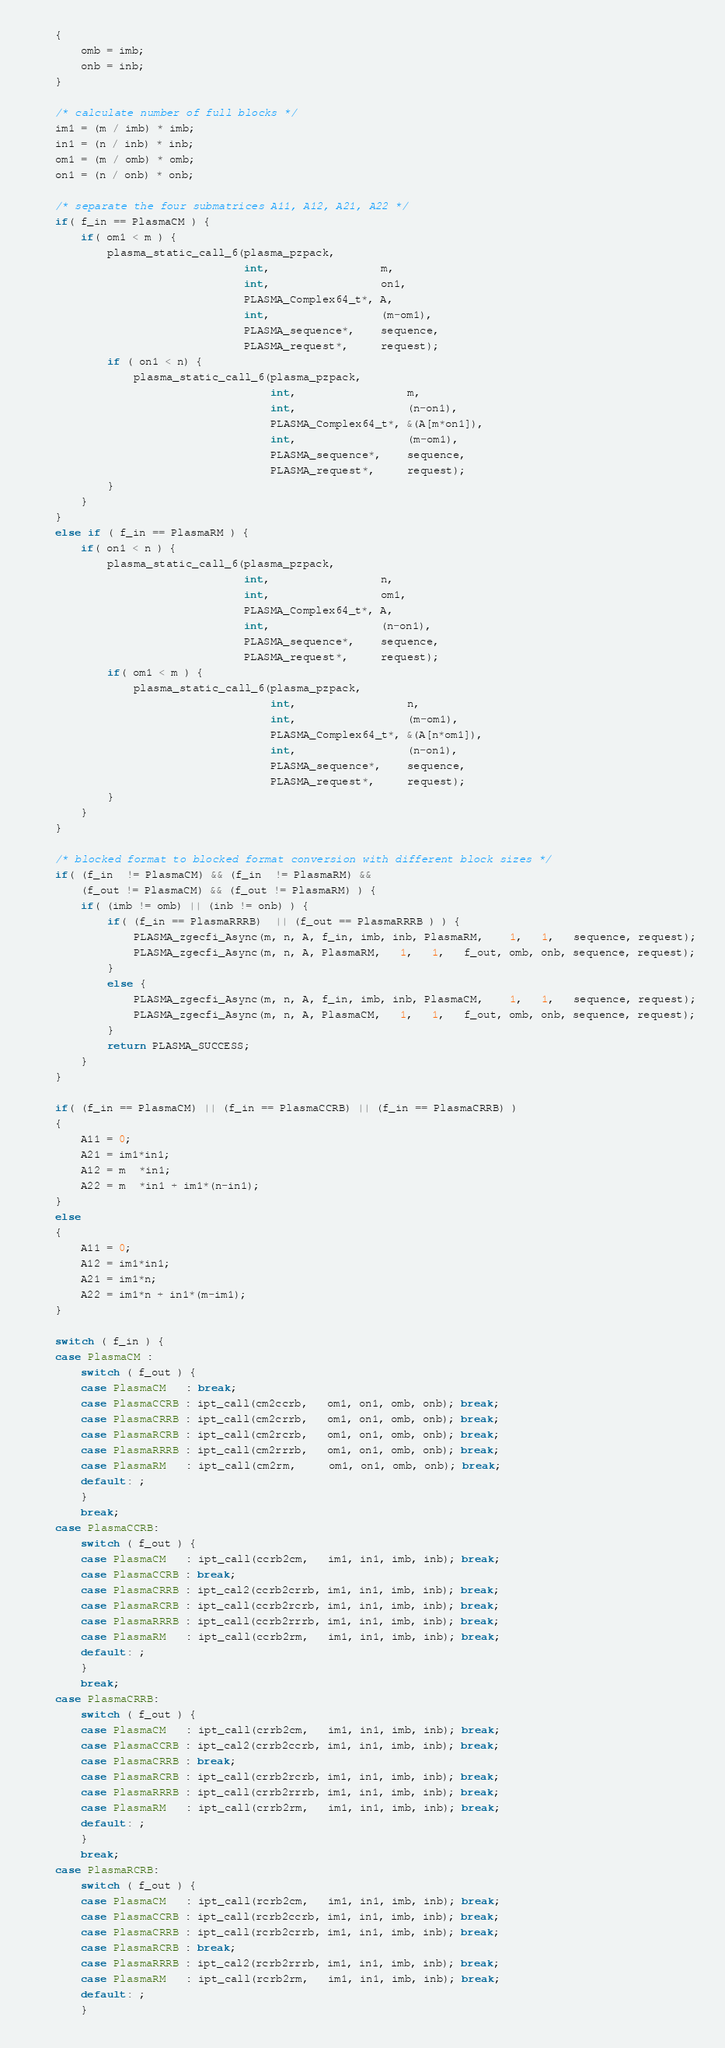Convert code to text. <code><loc_0><loc_0><loc_500><loc_500><_C_>    {
        omb = imb;
        onb = inb;
    }

    /* calculate number of full blocks */
    im1 = (m / imb) * imb;
    in1 = (n / inb) * inb;
    om1 = (m / omb) * omb;
    on1 = (n / onb) * onb;

    /* separate the four submatrices A11, A12, A21, A22 */
    if( f_in == PlasmaCM ) {
        if( om1 < m ) {
            plasma_static_call_6(plasma_pzpack,
                                 int,                 m,
                                 int,                 on1,
                                 PLASMA_Complex64_t*, A,
                                 int,                 (m-om1),
                                 PLASMA_sequence*,    sequence,
                                 PLASMA_request*,     request);
            if ( on1 < n) {
                plasma_static_call_6(plasma_pzpack,
                                     int,                 m,
                                     int,                 (n-on1),
                                     PLASMA_Complex64_t*, &(A[m*on1]),
                                     int,                 (m-om1),
                                     PLASMA_sequence*,    sequence,
                                     PLASMA_request*,     request);
            }
        }
    }
    else if ( f_in == PlasmaRM ) {
        if( on1 < n ) {
            plasma_static_call_6(plasma_pzpack,
                                 int,                 n,
                                 int,                 om1,
                                 PLASMA_Complex64_t*, A,
                                 int,                 (n-on1),
                                 PLASMA_sequence*,    sequence,
                                 PLASMA_request*,     request);
            if( om1 < m ) {
                plasma_static_call_6(plasma_pzpack,
                                     int,                 n,
                                     int,                 (m-om1),
                                     PLASMA_Complex64_t*, &(A[n*om1]),
                                     int,                 (n-on1),
                                     PLASMA_sequence*,    sequence,
                                     PLASMA_request*,     request);
            }
        }
    }

    /* blocked format to blocked format conversion with different block sizes */
    if( (f_in  != PlasmaCM) && (f_in  != PlasmaRM) &&
        (f_out != PlasmaCM) && (f_out != PlasmaRM) ) {
        if( (imb != omb) || (inb != onb) ) {
            if( (f_in == PlasmaRRRB)  || (f_out == PlasmaRRRB ) ) {
                PLASMA_zgecfi_Async(m, n, A, f_in, imb, inb, PlasmaRM,    1,   1,   sequence, request);
                PLASMA_zgecfi_Async(m, n, A, PlasmaRM,   1,   1,   f_out, omb, onb, sequence, request);
            }
            else {
                PLASMA_zgecfi_Async(m, n, A, f_in, imb, inb, PlasmaCM,    1,   1,   sequence, request);
                PLASMA_zgecfi_Async(m, n, A, PlasmaCM,   1,   1,   f_out, omb, onb, sequence, request);
            }
            return PLASMA_SUCCESS;
        }
    }

    if( (f_in == PlasmaCM) || (f_in == PlasmaCCRB) || (f_in == PlasmaCRRB) )
    {
        A11 = 0;
        A21 = im1*in1;
        A12 = m  *in1;
        A22 = m  *in1 + im1*(n-in1);
    }
    else
    {
        A11 = 0;
        A12 = im1*in1;
        A21 = im1*n;
        A22 = im1*n + in1*(m-im1);
    }

    switch ( f_in ) {
    case PlasmaCM :
        switch ( f_out ) {
        case PlasmaCM   : break;
        case PlasmaCCRB : ipt_call(cm2ccrb,   om1, on1, omb, onb); break;
        case PlasmaCRRB : ipt_call(cm2crrb,   om1, on1, omb, onb); break;
        case PlasmaRCRB : ipt_call(cm2rcrb,   om1, on1, omb, onb); break;
        case PlasmaRRRB : ipt_call(cm2rrrb,   om1, on1, omb, onb); break;
        case PlasmaRM   : ipt_call(cm2rm,     om1, on1, omb, onb); break;
        default: ;
        }
        break;
    case PlasmaCCRB:
        switch ( f_out ) {
        case PlasmaCM   : ipt_call(ccrb2cm,   im1, in1, imb, inb); break;
        case PlasmaCCRB : break;
        case PlasmaCRRB : ipt_cal2(ccrb2crrb, im1, in1, imb, inb); break;
        case PlasmaRCRB : ipt_call(ccrb2rcrb, im1, in1, imb, inb); break;
        case PlasmaRRRB : ipt_call(ccrb2rrrb, im1, in1, imb, inb); break;
        case PlasmaRM   : ipt_call(ccrb2rm,   im1, in1, imb, inb); break;
        default: ;
        }
        break;
    case PlasmaCRRB:
        switch ( f_out ) {
        case PlasmaCM   : ipt_call(crrb2cm,   im1, in1, imb, inb); break;
        case PlasmaCCRB : ipt_cal2(crrb2ccrb, im1, in1, imb, inb); break;
        case PlasmaCRRB : break;
        case PlasmaRCRB : ipt_call(crrb2rcrb, im1, in1, imb, inb); break;
        case PlasmaRRRB : ipt_call(crrb2rrrb, im1, in1, imb, inb); break;
        case PlasmaRM   : ipt_call(crrb2rm,   im1, in1, imb, inb); break;
        default: ;
        }
        break;
    case PlasmaRCRB:
        switch ( f_out ) {
        case PlasmaCM   : ipt_call(rcrb2cm,   im1, in1, imb, inb); break;
        case PlasmaCCRB : ipt_call(rcrb2ccrb, im1, in1, imb, inb); break;
        case PlasmaCRRB : ipt_call(rcrb2crrb, im1, in1, imb, inb); break;
        case PlasmaRCRB : break;
        case PlasmaRRRB : ipt_cal2(rcrb2rrrb, im1, in1, imb, inb); break;
        case PlasmaRM   : ipt_call(rcrb2rm,   im1, in1, imb, inb); break;
        default: ;
        }</code> 